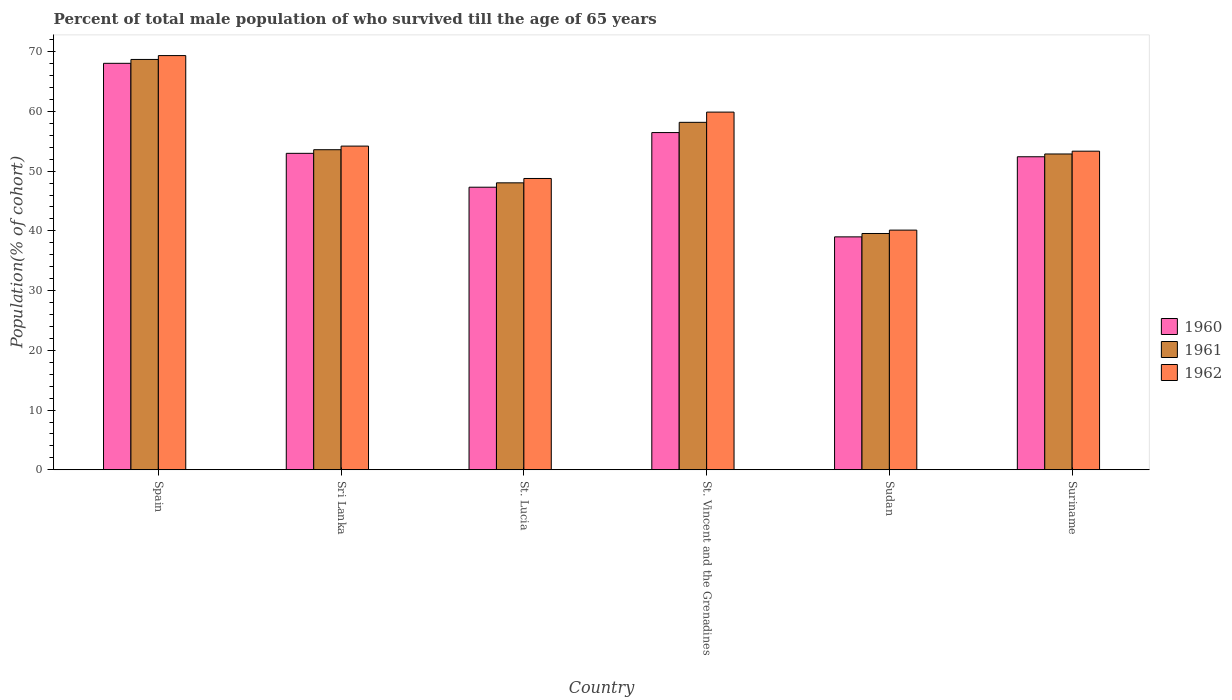Are the number of bars on each tick of the X-axis equal?
Ensure brevity in your answer.  Yes. What is the label of the 6th group of bars from the left?
Your answer should be compact. Suriname. What is the percentage of total male population who survived till the age of 65 years in 1961 in Sri Lanka?
Keep it short and to the point. 53.58. Across all countries, what is the maximum percentage of total male population who survived till the age of 65 years in 1960?
Keep it short and to the point. 68.04. Across all countries, what is the minimum percentage of total male population who survived till the age of 65 years in 1962?
Keep it short and to the point. 40.12. In which country was the percentage of total male population who survived till the age of 65 years in 1961 maximum?
Provide a succinct answer. Spain. In which country was the percentage of total male population who survived till the age of 65 years in 1960 minimum?
Ensure brevity in your answer.  Sudan. What is the total percentage of total male population who survived till the age of 65 years in 1962 in the graph?
Your answer should be compact. 325.63. What is the difference between the percentage of total male population who survived till the age of 65 years in 1962 in St. Lucia and that in Suriname?
Keep it short and to the point. -4.57. What is the difference between the percentage of total male population who survived till the age of 65 years in 1962 in Sri Lanka and the percentage of total male population who survived till the age of 65 years in 1961 in Spain?
Provide a succinct answer. -14.5. What is the average percentage of total male population who survived till the age of 65 years in 1961 per country?
Give a very brief answer. 53.48. What is the difference between the percentage of total male population who survived till the age of 65 years of/in 1960 and percentage of total male population who survived till the age of 65 years of/in 1962 in Sri Lanka?
Your answer should be compact. -1.21. In how many countries, is the percentage of total male population who survived till the age of 65 years in 1961 greater than 16 %?
Keep it short and to the point. 6. What is the ratio of the percentage of total male population who survived till the age of 65 years in 1962 in Sri Lanka to that in St. Lucia?
Keep it short and to the point. 1.11. Is the difference between the percentage of total male population who survived till the age of 65 years in 1960 in St. Lucia and St. Vincent and the Grenadines greater than the difference between the percentage of total male population who survived till the age of 65 years in 1962 in St. Lucia and St. Vincent and the Grenadines?
Offer a terse response. Yes. What is the difference between the highest and the second highest percentage of total male population who survived till the age of 65 years in 1960?
Offer a very short reply. -11.59. What is the difference between the highest and the lowest percentage of total male population who survived till the age of 65 years in 1960?
Your answer should be compact. 29.05. In how many countries, is the percentage of total male population who survived till the age of 65 years in 1960 greater than the average percentage of total male population who survived till the age of 65 years in 1960 taken over all countries?
Give a very brief answer. 3. What does the 1st bar from the left in St. Vincent and the Grenadines represents?
Give a very brief answer. 1960. Are the values on the major ticks of Y-axis written in scientific E-notation?
Provide a succinct answer. No. Does the graph contain any zero values?
Give a very brief answer. No. Does the graph contain grids?
Ensure brevity in your answer.  No. What is the title of the graph?
Give a very brief answer. Percent of total male population of who survived till the age of 65 years. Does "2012" appear as one of the legend labels in the graph?
Ensure brevity in your answer.  No. What is the label or title of the X-axis?
Your answer should be compact. Country. What is the label or title of the Y-axis?
Give a very brief answer. Population(% of cohort). What is the Population(% of cohort) of 1960 in Spain?
Keep it short and to the point. 68.04. What is the Population(% of cohort) of 1961 in Spain?
Provide a succinct answer. 68.69. What is the Population(% of cohort) in 1962 in Spain?
Keep it short and to the point. 69.34. What is the Population(% of cohort) in 1960 in Sri Lanka?
Your response must be concise. 52.97. What is the Population(% of cohort) in 1961 in Sri Lanka?
Offer a terse response. 53.58. What is the Population(% of cohort) in 1962 in Sri Lanka?
Ensure brevity in your answer.  54.19. What is the Population(% of cohort) in 1960 in St. Lucia?
Provide a succinct answer. 47.31. What is the Population(% of cohort) in 1961 in St. Lucia?
Ensure brevity in your answer.  48.04. What is the Population(% of cohort) of 1962 in St. Lucia?
Offer a very short reply. 48.77. What is the Population(% of cohort) of 1960 in St. Vincent and the Grenadines?
Provide a short and direct response. 56.45. What is the Population(% of cohort) of 1961 in St. Vincent and the Grenadines?
Offer a terse response. 58.16. What is the Population(% of cohort) in 1962 in St. Vincent and the Grenadines?
Provide a short and direct response. 59.88. What is the Population(% of cohort) of 1960 in Sudan?
Your answer should be compact. 38.99. What is the Population(% of cohort) in 1961 in Sudan?
Provide a short and direct response. 39.56. What is the Population(% of cohort) in 1962 in Sudan?
Provide a short and direct response. 40.12. What is the Population(% of cohort) in 1960 in Suriname?
Make the answer very short. 52.4. What is the Population(% of cohort) in 1961 in Suriname?
Make the answer very short. 52.87. What is the Population(% of cohort) of 1962 in Suriname?
Offer a very short reply. 53.34. Across all countries, what is the maximum Population(% of cohort) of 1960?
Ensure brevity in your answer.  68.04. Across all countries, what is the maximum Population(% of cohort) in 1961?
Your answer should be compact. 68.69. Across all countries, what is the maximum Population(% of cohort) in 1962?
Offer a terse response. 69.34. Across all countries, what is the minimum Population(% of cohort) in 1960?
Ensure brevity in your answer.  38.99. Across all countries, what is the minimum Population(% of cohort) of 1961?
Provide a succinct answer. 39.56. Across all countries, what is the minimum Population(% of cohort) in 1962?
Provide a succinct answer. 40.12. What is the total Population(% of cohort) in 1960 in the graph?
Provide a succinct answer. 316.17. What is the total Population(% of cohort) in 1961 in the graph?
Offer a very short reply. 320.9. What is the total Population(% of cohort) of 1962 in the graph?
Provide a short and direct response. 325.63. What is the difference between the Population(% of cohort) of 1960 in Spain and that in Sri Lanka?
Ensure brevity in your answer.  15.07. What is the difference between the Population(% of cohort) of 1961 in Spain and that in Sri Lanka?
Provide a short and direct response. 15.11. What is the difference between the Population(% of cohort) of 1962 in Spain and that in Sri Lanka?
Make the answer very short. 15.15. What is the difference between the Population(% of cohort) of 1960 in Spain and that in St. Lucia?
Make the answer very short. 20.74. What is the difference between the Population(% of cohort) of 1961 in Spain and that in St. Lucia?
Your response must be concise. 20.66. What is the difference between the Population(% of cohort) of 1962 in Spain and that in St. Lucia?
Provide a succinct answer. 20.57. What is the difference between the Population(% of cohort) in 1960 in Spain and that in St. Vincent and the Grenadines?
Offer a very short reply. 11.59. What is the difference between the Population(% of cohort) of 1961 in Spain and that in St. Vincent and the Grenadines?
Your answer should be very brief. 10.53. What is the difference between the Population(% of cohort) of 1962 in Spain and that in St. Vincent and the Grenadines?
Make the answer very short. 9.46. What is the difference between the Population(% of cohort) in 1960 in Spain and that in Sudan?
Your response must be concise. 29.05. What is the difference between the Population(% of cohort) in 1961 in Spain and that in Sudan?
Ensure brevity in your answer.  29.13. What is the difference between the Population(% of cohort) of 1962 in Spain and that in Sudan?
Ensure brevity in your answer.  29.21. What is the difference between the Population(% of cohort) of 1960 in Spain and that in Suriname?
Make the answer very short. 15.64. What is the difference between the Population(% of cohort) in 1961 in Spain and that in Suriname?
Keep it short and to the point. 15.82. What is the difference between the Population(% of cohort) of 1962 in Spain and that in Suriname?
Offer a terse response. 16. What is the difference between the Population(% of cohort) of 1960 in Sri Lanka and that in St. Lucia?
Give a very brief answer. 5.67. What is the difference between the Population(% of cohort) of 1961 in Sri Lanka and that in St. Lucia?
Your response must be concise. 5.54. What is the difference between the Population(% of cohort) in 1962 in Sri Lanka and that in St. Lucia?
Keep it short and to the point. 5.42. What is the difference between the Population(% of cohort) of 1960 in Sri Lanka and that in St. Vincent and the Grenadines?
Your answer should be compact. -3.48. What is the difference between the Population(% of cohort) of 1961 in Sri Lanka and that in St. Vincent and the Grenadines?
Make the answer very short. -4.58. What is the difference between the Population(% of cohort) in 1962 in Sri Lanka and that in St. Vincent and the Grenadines?
Make the answer very short. -5.69. What is the difference between the Population(% of cohort) in 1960 in Sri Lanka and that in Sudan?
Ensure brevity in your answer.  13.98. What is the difference between the Population(% of cohort) of 1961 in Sri Lanka and that in Sudan?
Make the answer very short. 14.02. What is the difference between the Population(% of cohort) of 1962 in Sri Lanka and that in Sudan?
Offer a very short reply. 14.06. What is the difference between the Population(% of cohort) of 1960 in Sri Lanka and that in Suriname?
Your answer should be very brief. 0.57. What is the difference between the Population(% of cohort) of 1961 in Sri Lanka and that in Suriname?
Give a very brief answer. 0.71. What is the difference between the Population(% of cohort) in 1962 in Sri Lanka and that in Suriname?
Make the answer very short. 0.85. What is the difference between the Population(% of cohort) in 1960 in St. Lucia and that in St. Vincent and the Grenadines?
Offer a terse response. -9.15. What is the difference between the Population(% of cohort) of 1961 in St. Lucia and that in St. Vincent and the Grenadines?
Keep it short and to the point. -10.13. What is the difference between the Population(% of cohort) in 1962 in St. Lucia and that in St. Vincent and the Grenadines?
Offer a very short reply. -11.11. What is the difference between the Population(% of cohort) in 1960 in St. Lucia and that in Sudan?
Provide a succinct answer. 8.31. What is the difference between the Population(% of cohort) of 1961 in St. Lucia and that in Sudan?
Provide a succinct answer. 8.48. What is the difference between the Population(% of cohort) in 1962 in St. Lucia and that in Sudan?
Offer a very short reply. 8.64. What is the difference between the Population(% of cohort) of 1960 in St. Lucia and that in Suriname?
Ensure brevity in your answer.  -5.1. What is the difference between the Population(% of cohort) in 1961 in St. Lucia and that in Suriname?
Provide a short and direct response. -4.83. What is the difference between the Population(% of cohort) of 1962 in St. Lucia and that in Suriname?
Provide a short and direct response. -4.57. What is the difference between the Population(% of cohort) of 1960 in St. Vincent and the Grenadines and that in Sudan?
Your answer should be very brief. 17.46. What is the difference between the Population(% of cohort) of 1961 in St. Vincent and the Grenadines and that in Sudan?
Provide a succinct answer. 18.61. What is the difference between the Population(% of cohort) in 1962 in St. Vincent and the Grenadines and that in Sudan?
Your answer should be compact. 19.75. What is the difference between the Population(% of cohort) of 1960 in St. Vincent and the Grenadines and that in Suriname?
Keep it short and to the point. 4.05. What is the difference between the Population(% of cohort) of 1961 in St. Vincent and the Grenadines and that in Suriname?
Provide a succinct answer. 5.3. What is the difference between the Population(% of cohort) in 1962 in St. Vincent and the Grenadines and that in Suriname?
Offer a terse response. 6.54. What is the difference between the Population(% of cohort) in 1960 in Sudan and that in Suriname?
Your response must be concise. -13.41. What is the difference between the Population(% of cohort) in 1961 in Sudan and that in Suriname?
Make the answer very short. -13.31. What is the difference between the Population(% of cohort) in 1962 in Sudan and that in Suriname?
Your answer should be very brief. -13.21. What is the difference between the Population(% of cohort) in 1960 in Spain and the Population(% of cohort) in 1961 in Sri Lanka?
Your response must be concise. 14.46. What is the difference between the Population(% of cohort) of 1960 in Spain and the Population(% of cohort) of 1962 in Sri Lanka?
Keep it short and to the point. 13.86. What is the difference between the Population(% of cohort) of 1961 in Spain and the Population(% of cohort) of 1962 in Sri Lanka?
Your answer should be very brief. 14.5. What is the difference between the Population(% of cohort) in 1960 in Spain and the Population(% of cohort) in 1961 in St. Lucia?
Give a very brief answer. 20.01. What is the difference between the Population(% of cohort) in 1960 in Spain and the Population(% of cohort) in 1962 in St. Lucia?
Your answer should be very brief. 19.28. What is the difference between the Population(% of cohort) in 1961 in Spain and the Population(% of cohort) in 1962 in St. Lucia?
Provide a short and direct response. 19.93. What is the difference between the Population(% of cohort) in 1960 in Spain and the Population(% of cohort) in 1961 in St. Vincent and the Grenadines?
Your response must be concise. 9.88. What is the difference between the Population(% of cohort) in 1960 in Spain and the Population(% of cohort) in 1962 in St. Vincent and the Grenadines?
Your answer should be compact. 8.17. What is the difference between the Population(% of cohort) in 1961 in Spain and the Population(% of cohort) in 1962 in St. Vincent and the Grenadines?
Make the answer very short. 8.81. What is the difference between the Population(% of cohort) of 1960 in Spain and the Population(% of cohort) of 1961 in Sudan?
Provide a short and direct response. 28.49. What is the difference between the Population(% of cohort) in 1960 in Spain and the Population(% of cohort) in 1962 in Sudan?
Keep it short and to the point. 27.92. What is the difference between the Population(% of cohort) in 1961 in Spain and the Population(% of cohort) in 1962 in Sudan?
Your answer should be very brief. 28.57. What is the difference between the Population(% of cohort) in 1960 in Spain and the Population(% of cohort) in 1961 in Suriname?
Give a very brief answer. 15.18. What is the difference between the Population(% of cohort) in 1960 in Spain and the Population(% of cohort) in 1962 in Suriname?
Provide a succinct answer. 14.71. What is the difference between the Population(% of cohort) in 1961 in Spain and the Population(% of cohort) in 1962 in Suriname?
Your response must be concise. 15.36. What is the difference between the Population(% of cohort) of 1960 in Sri Lanka and the Population(% of cohort) of 1961 in St. Lucia?
Provide a short and direct response. 4.94. What is the difference between the Population(% of cohort) in 1960 in Sri Lanka and the Population(% of cohort) in 1962 in St. Lucia?
Offer a very short reply. 4.21. What is the difference between the Population(% of cohort) of 1961 in Sri Lanka and the Population(% of cohort) of 1962 in St. Lucia?
Provide a succinct answer. 4.81. What is the difference between the Population(% of cohort) of 1960 in Sri Lanka and the Population(% of cohort) of 1961 in St. Vincent and the Grenadines?
Ensure brevity in your answer.  -5.19. What is the difference between the Population(% of cohort) of 1960 in Sri Lanka and the Population(% of cohort) of 1962 in St. Vincent and the Grenadines?
Offer a terse response. -6.9. What is the difference between the Population(% of cohort) in 1961 in Sri Lanka and the Population(% of cohort) in 1962 in St. Vincent and the Grenadines?
Offer a terse response. -6.3. What is the difference between the Population(% of cohort) in 1960 in Sri Lanka and the Population(% of cohort) in 1961 in Sudan?
Provide a succinct answer. 13.42. What is the difference between the Population(% of cohort) in 1960 in Sri Lanka and the Population(% of cohort) in 1962 in Sudan?
Provide a succinct answer. 12.85. What is the difference between the Population(% of cohort) of 1961 in Sri Lanka and the Population(% of cohort) of 1962 in Sudan?
Offer a terse response. 13.46. What is the difference between the Population(% of cohort) in 1960 in Sri Lanka and the Population(% of cohort) in 1961 in Suriname?
Offer a very short reply. 0.11. What is the difference between the Population(% of cohort) in 1960 in Sri Lanka and the Population(% of cohort) in 1962 in Suriname?
Provide a succinct answer. -0.36. What is the difference between the Population(% of cohort) in 1961 in Sri Lanka and the Population(% of cohort) in 1962 in Suriname?
Your response must be concise. 0.24. What is the difference between the Population(% of cohort) in 1960 in St. Lucia and the Population(% of cohort) in 1961 in St. Vincent and the Grenadines?
Ensure brevity in your answer.  -10.86. What is the difference between the Population(% of cohort) of 1960 in St. Lucia and the Population(% of cohort) of 1962 in St. Vincent and the Grenadines?
Provide a succinct answer. -12.57. What is the difference between the Population(% of cohort) of 1961 in St. Lucia and the Population(% of cohort) of 1962 in St. Vincent and the Grenadines?
Ensure brevity in your answer.  -11.84. What is the difference between the Population(% of cohort) in 1960 in St. Lucia and the Population(% of cohort) in 1961 in Sudan?
Your answer should be very brief. 7.75. What is the difference between the Population(% of cohort) of 1960 in St. Lucia and the Population(% of cohort) of 1962 in Sudan?
Give a very brief answer. 7.18. What is the difference between the Population(% of cohort) of 1961 in St. Lucia and the Population(% of cohort) of 1962 in Sudan?
Ensure brevity in your answer.  7.91. What is the difference between the Population(% of cohort) of 1960 in St. Lucia and the Population(% of cohort) of 1961 in Suriname?
Provide a succinct answer. -5.56. What is the difference between the Population(% of cohort) of 1960 in St. Lucia and the Population(% of cohort) of 1962 in Suriname?
Make the answer very short. -6.03. What is the difference between the Population(% of cohort) in 1960 in St. Vincent and the Grenadines and the Population(% of cohort) in 1961 in Sudan?
Provide a succinct answer. 16.89. What is the difference between the Population(% of cohort) of 1960 in St. Vincent and the Grenadines and the Population(% of cohort) of 1962 in Sudan?
Give a very brief answer. 16.33. What is the difference between the Population(% of cohort) in 1961 in St. Vincent and the Grenadines and the Population(% of cohort) in 1962 in Sudan?
Offer a very short reply. 18.04. What is the difference between the Population(% of cohort) of 1960 in St. Vincent and the Grenadines and the Population(% of cohort) of 1961 in Suriname?
Offer a terse response. 3.58. What is the difference between the Population(% of cohort) in 1960 in St. Vincent and the Grenadines and the Population(% of cohort) in 1962 in Suriname?
Your answer should be very brief. 3.12. What is the difference between the Population(% of cohort) of 1961 in St. Vincent and the Grenadines and the Population(% of cohort) of 1962 in Suriname?
Your answer should be compact. 4.83. What is the difference between the Population(% of cohort) in 1960 in Sudan and the Population(% of cohort) in 1961 in Suriname?
Ensure brevity in your answer.  -13.88. What is the difference between the Population(% of cohort) in 1960 in Sudan and the Population(% of cohort) in 1962 in Suriname?
Your answer should be very brief. -14.34. What is the difference between the Population(% of cohort) in 1961 in Sudan and the Population(% of cohort) in 1962 in Suriname?
Your answer should be compact. -13.78. What is the average Population(% of cohort) of 1960 per country?
Your answer should be compact. 52.7. What is the average Population(% of cohort) in 1961 per country?
Keep it short and to the point. 53.48. What is the average Population(% of cohort) in 1962 per country?
Offer a terse response. 54.27. What is the difference between the Population(% of cohort) of 1960 and Population(% of cohort) of 1961 in Spain?
Your response must be concise. -0.65. What is the difference between the Population(% of cohort) in 1960 and Population(% of cohort) in 1962 in Spain?
Keep it short and to the point. -1.29. What is the difference between the Population(% of cohort) of 1961 and Population(% of cohort) of 1962 in Spain?
Offer a terse response. -0.65. What is the difference between the Population(% of cohort) in 1960 and Population(% of cohort) in 1961 in Sri Lanka?
Your answer should be very brief. -0.61. What is the difference between the Population(% of cohort) in 1960 and Population(% of cohort) in 1962 in Sri Lanka?
Give a very brief answer. -1.21. What is the difference between the Population(% of cohort) in 1961 and Population(% of cohort) in 1962 in Sri Lanka?
Provide a succinct answer. -0.61. What is the difference between the Population(% of cohort) of 1960 and Population(% of cohort) of 1961 in St. Lucia?
Your response must be concise. -0.73. What is the difference between the Population(% of cohort) in 1960 and Population(% of cohort) in 1962 in St. Lucia?
Your answer should be very brief. -1.46. What is the difference between the Population(% of cohort) of 1961 and Population(% of cohort) of 1962 in St. Lucia?
Your response must be concise. -0.73. What is the difference between the Population(% of cohort) in 1960 and Population(% of cohort) in 1961 in St. Vincent and the Grenadines?
Offer a very short reply. -1.71. What is the difference between the Population(% of cohort) in 1960 and Population(% of cohort) in 1962 in St. Vincent and the Grenadines?
Offer a very short reply. -3.43. What is the difference between the Population(% of cohort) of 1961 and Population(% of cohort) of 1962 in St. Vincent and the Grenadines?
Offer a terse response. -1.71. What is the difference between the Population(% of cohort) of 1960 and Population(% of cohort) of 1961 in Sudan?
Provide a short and direct response. -0.57. What is the difference between the Population(% of cohort) in 1960 and Population(% of cohort) in 1962 in Sudan?
Offer a very short reply. -1.13. What is the difference between the Population(% of cohort) in 1961 and Population(% of cohort) in 1962 in Sudan?
Offer a terse response. -0.57. What is the difference between the Population(% of cohort) of 1960 and Population(% of cohort) of 1961 in Suriname?
Ensure brevity in your answer.  -0.47. What is the difference between the Population(% of cohort) of 1960 and Population(% of cohort) of 1962 in Suriname?
Ensure brevity in your answer.  -0.93. What is the difference between the Population(% of cohort) in 1961 and Population(% of cohort) in 1962 in Suriname?
Provide a succinct answer. -0.47. What is the ratio of the Population(% of cohort) of 1960 in Spain to that in Sri Lanka?
Provide a short and direct response. 1.28. What is the ratio of the Population(% of cohort) in 1961 in Spain to that in Sri Lanka?
Your response must be concise. 1.28. What is the ratio of the Population(% of cohort) of 1962 in Spain to that in Sri Lanka?
Provide a short and direct response. 1.28. What is the ratio of the Population(% of cohort) in 1960 in Spain to that in St. Lucia?
Provide a short and direct response. 1.44. What is the ratio of the Population(% of cohort) in 1961 in Spain to that in St. Lucia?
Provide a short and direct response. 1.43. What is the ratio of the Population(% of cohort) in 1962 in Spain to that in St. Lucia?
Provide a succinct answer. 1.42. What is the ratio of the Population(% of cohort) of 1960 in Spain to that in St. Vincent and the Grenadines?
Offer a terse response. 1.21. What is the ratio of the Population(% of cohort) in 1961 in Spain to that in St. Vincent and the Grenadines?
Offer a very short reply. 1.18. What is the ratio of the Population(% of cohort) in 1962 in Spain to that in St. Vincent and the Grenadines?
Offer a very short reply. 1.16. What is the ratio of the Population(% of cohort) in 1960 in Spain to that in Sudan?
Your response must be concise. 1.75. What is the ratio of the Population(% of cohort) in 1961 in Spain to that in Sudan?
Your response must be concise. 1.74. What is the ratio of the Population(% of cohort) in 1962 in Spain to that in Sudan?
Ensure brevity in your answer.  1.73. What is the ratio of the Population(% of cohort) of 1960 in Spain to that in Suriname?
Offer a very short reply. 1.3. What is the ratio of the Population(% of cohort) of 1961 in Spain to that in Suriname?
Offer a terse response. 1.3. What is the ratio of the Population(% of cohort) of 1962 in Spain to that in Suriname?
Give a very brief answer. 1.3. What is the ratio of the Population(% of cohort) of 1960 in Sri Lanka to that in St. Lucia?
Provide a short and direct response. 1.12. What is the ratio of the Population(% of cohort) in 1961 in Sri Lanka to that in St. Lucia?
Offer a terse response. 1.12. What is the ratio of the Population(% of cohort) in 1962 in Sri Lanka to that in St. Lucia?
Make the answer very short. 1.11. What is the ratio of the Population(% of cohort) in 1960 in Sri Lanka to that in St. Vincent and the Grenadines?
Your answer should be compact. 0.94. What is the ratio of the Population(% of cohort) in 1961 in Sri Lanka to that in St. Vincent and the Grenadines?
Keep it short and to the point. 0.92. What is the ratio of the Population(% of cohort) of 1962 in Sri Lanka to that in St. Vincent and the Grenadines?
Ensure brevity in your answer.  0.91. What is the ratio of the Population(% of cohort) of 1960 in Sri Lanka to that in Sudan?
Give a very brief answer. 1.36. What is the ratio of the Population(% of cohort) in 1961 in Sri Lanka to that in Sudan?
Your response must be concise. 1.35. What is the ratio of the Population(% of cohort) of 1962 in Sri Lanka to that in Sudan?
Ensure brevity in your answer.  1.35. What is the ratio of the Population(% of cohort) of 1960 in Sri Lanka to that in Suriname?
Keep it short and to the point. 1.01. What is the ratio of the Population(% of cohort) in 1961 in Sri Lanka to that in Suriname?
Offer a very short reply. 1.01. What is the ratio of the Population(% of cohort) in 1960 in St. Lucia to that in St. Vincent and the Grenadines?
Keep it short and to the point. 0.84. What is the ratio of the Population(% of cohort) in 1961 in St. Lucia to that in St. Vincent and the Grenadines?
Make the answer very short. 0.83. What is the ratio of the Population(% of cohort) of 1962 in St. Lucia to that in St. Vincent and the Grenadines?
Keep it short and to the point. 0.81. What is the ratio of the Population(% of cohort) in 1960 in St. Lucia to that in Sudan?
Ensure brevity in your answer.  1.21. What is the ratio of the Population(% of cohort) in 1961 in St. Lucia to that in Sudan?
Your answer should be compact. 1.21. What is the ratio of the Population(% of cohort) in 1962 in St. Lucia to that in Sudan?
Ensure brevity in your answer.  1.22. What is the ratio of the Population(% of cohort) in 1960 in St. Lucia to that in Suriname?
Your answer should be very brief. 0.9. What is the ratio of the Population(% of cohort) of 1961 in St. Lucia to that in Suriname?
Offer a terse response. 0.91. What is the ratio of the Population(% of cohort) of 1962 in St. Lucia to that in Suriname?
Provide a short and direct response. 0.91. What is the ratio of the Population(% of cohort) in 1960 in St. Vincent and the Grenadines to that in Sudan?
Keep it short and to the point. 1.45. What is the ratio of the Population(% of cohort) of 1961 in St. Vincent and the Grenadines to that in Sudan?
Your response must be concise. 1.47. What is the ratio of the Population(% of cohort) in 1962 in St. Vincent and the Grenadines to that in Sudan?
Offer a very short reply. 1.49. What is the ratio of the Population(% of cohort) in 1960 in St. Vincent and the Grenadines to that in Suriname?
Your answer should be very brief. 1.08. What is the ratio of the Population(% of cohort) in 1961 in St. Vincent and the Grenadines to that in Suriname?
Offer a very short reply. 1.1. What is the ratio of the Population(% of cohort) in 1962 in St. Vincent and the Grenadines to that in Suriname?
Provide a short and direct response. 1.12. What is the ratio of the Population(% of cohort) of 1960 in Sudan to that in Suriname?
Offer a very short reply. 0.74. What is the ratio of the Population(% of cohort) of 1961 in Sudan to that in Suriname?
Make the answer very short. 0.75. What is the ratio of the Population(% of cohort) in 1962 in Sudan to that in Suriname?
Your answer should be very brief. 0.75. What is the difference between the highest and the second highest Population(% of cohort) of 1960?
Offer a terse response. 11.59. What is the difference between the highest and the second highest Population(% of cohort) of 1961?
Offer a very short reply. 10.53. What is the difference between the highest and the second highest Population(% of cohort) of 1962?
Your answer should be very brief. 9.46. What is the difference between the highest and the lowest Population(% of cohort) in 1960?
Give a very brief answer. 29.05. What is the difference between the highest and the lowest Population(% of cohort) of 1961?
Keep it short and to the point. 29.13. What is the difference between the highest and the lowest Population(% of cohort) of 1962?
Provide a succinct answer. 29.21. 